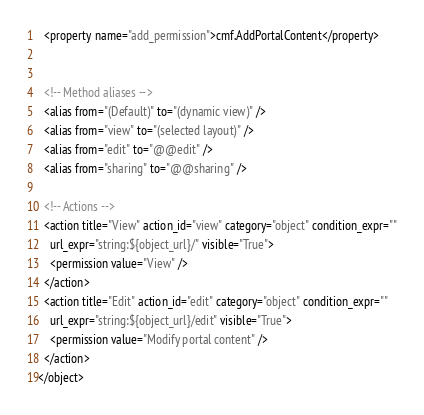Convert code to text. <code><loc_0><loc_0><loc_500><loc_500><_XML_>  <property name="add_permission">cmf.AddPortalContent</property>


  <!-- Method aliases -->
  <alias from="(Default)" to="(dynamic view)" />
  <alias from="view" to="(selected layout)" />
  <alias from="edit" to="@@edit" />
  <alias from="sharing" to="@@sharing" />

  <!-- Actions -->
  <action title="View" action_id="view" category="object" condition_expr=""
    url_expr="string:${object_url}/" visible="True">
    <permission value="View" />
  </action>
  <action title="Edit" action_id="edit" category="object" condition_expr=""
    url_expr="string:${object_url}/edit" visible="True">
    <permission value="Modify portal content" />
  </action>
</object>
</code> 